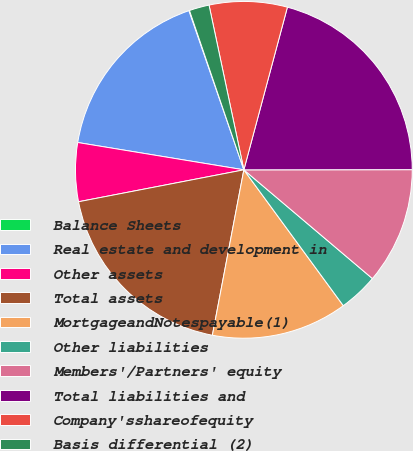Convert chart to OTSL. <chart><loc_0><loc_0><loc_500><loc_500><pie_chart><fcel>Balance Sheets<fcel>Real estate and development in<fcel>Other assets<fcel>Total assets<fcel>MortgageandNotespayable(1)<fcel>Other liabilities<fcel>Members'/Partners' equity<fcel>Total liabilities and<fcel>Company'sshareofequity<fcel>Basis differential (2)<nl><fcel>0.06%<fcel>17.11%<fcel>5.63%<fcel>18.97%<fcel>13.05%<fcel>3.77%<fcel>11.19%<fcel>20.82%<fcel>7.48%<fcel>1.92%<nl></chart> 